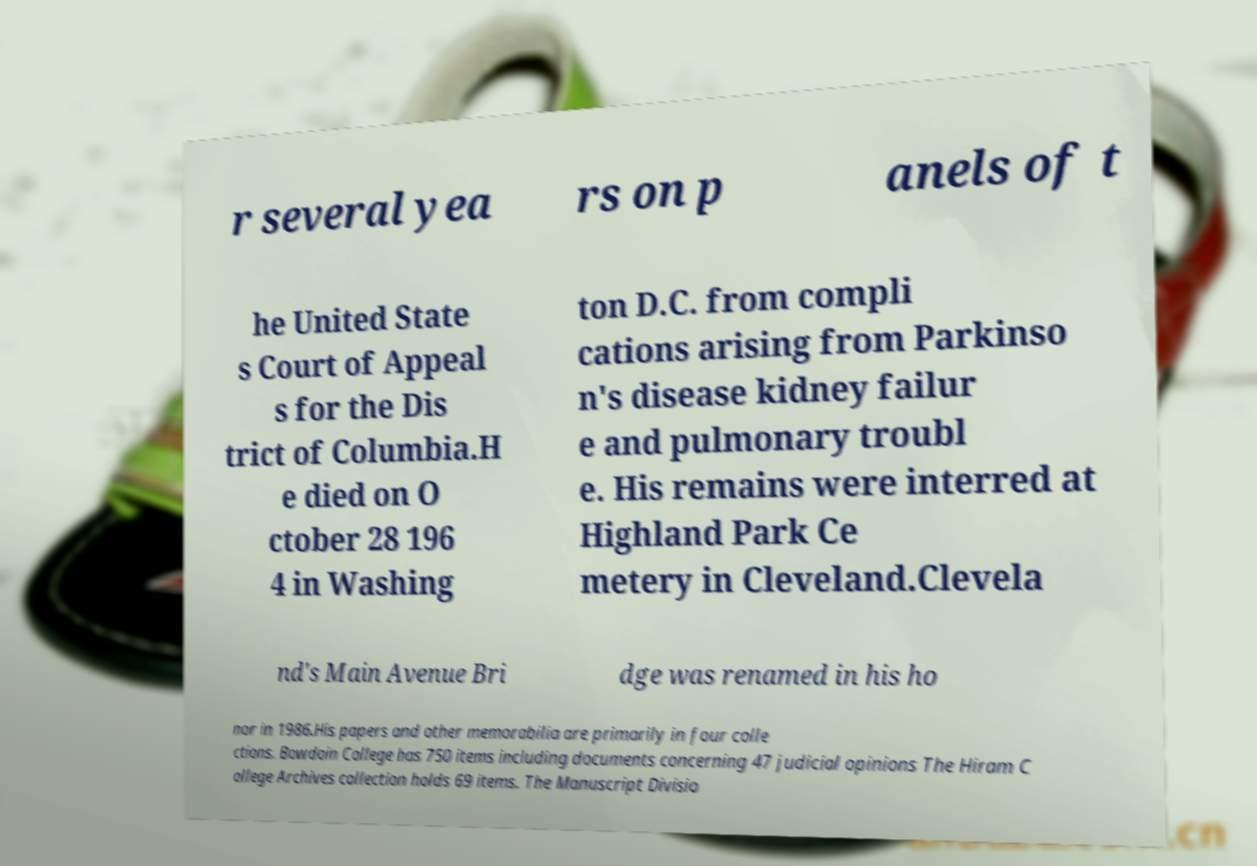Could you assist in decoding the text presented in this image and type it out clearly? r several yea rs on p anels of t he United State s Court of Appeal s for the Dis trict of Columbia.H e died on O ctober 28 196 4 in Washing ton D.C. from compli cations arising from Parkinso n's disease kidney failur e and pulmonary troubl e. His remains were interred at Highland Park Ce metery in Cleveland.Clevela nd's Main Avenue Bri dge was renamed in his ho nor in 1986.His papers and other memorabilia are primarily in four colle ctions. Bowdoin College has 750 items including documents concerning 47 judicial opinions The Hiram C ollege Archives collection holds 69 items. The Manuscript Divisio 